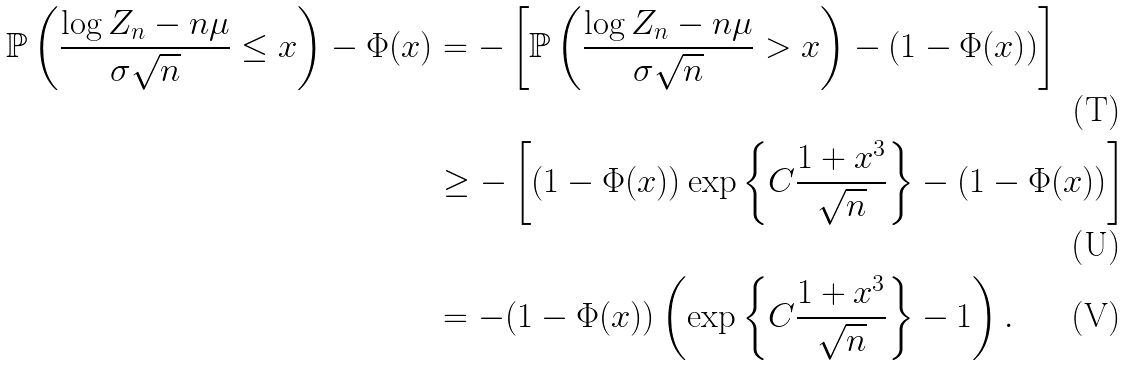Convert formula to latex. <formula><loc_0><loc_0><loc_500><loc_500>\mathbb { P } \left ( \frac { \log Z _ { n } - n \mu } { \sigma \sqrt { n } } \leq x \right ) - \Phi ( x ) & = - \left [ \mathbb { P } \left ( \frac { \log Z _ { n } - n \mu } { \sigma \sqrt { n } } > x \right ) - ( 1 - \Phi ( x ) ) \right ] \\ & \geq - \left [ ( 1 - \Phi ( x ) ) \exp \left \{ C \frac { 1 + x ^ { 3 } } { \sqrt { n } } \right \} - ( 1 - \Phi ( x ) ) \right ] \\ & = - ( 1 - \Phi ( x ) ) \left ( \exp \left \{ C \frac { 1 + x ^ { 3 } } { \sqrt { n } } \right \} - 1 \right ) .</formula> 